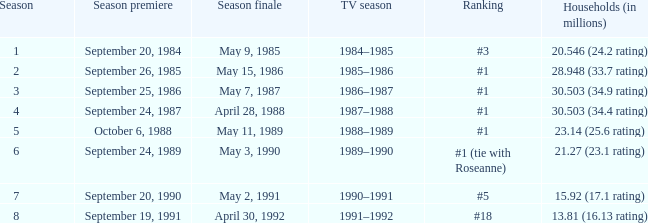Which TV season has Households (in millions) of 30.503 (34.9 rating)? 1986–1987. 